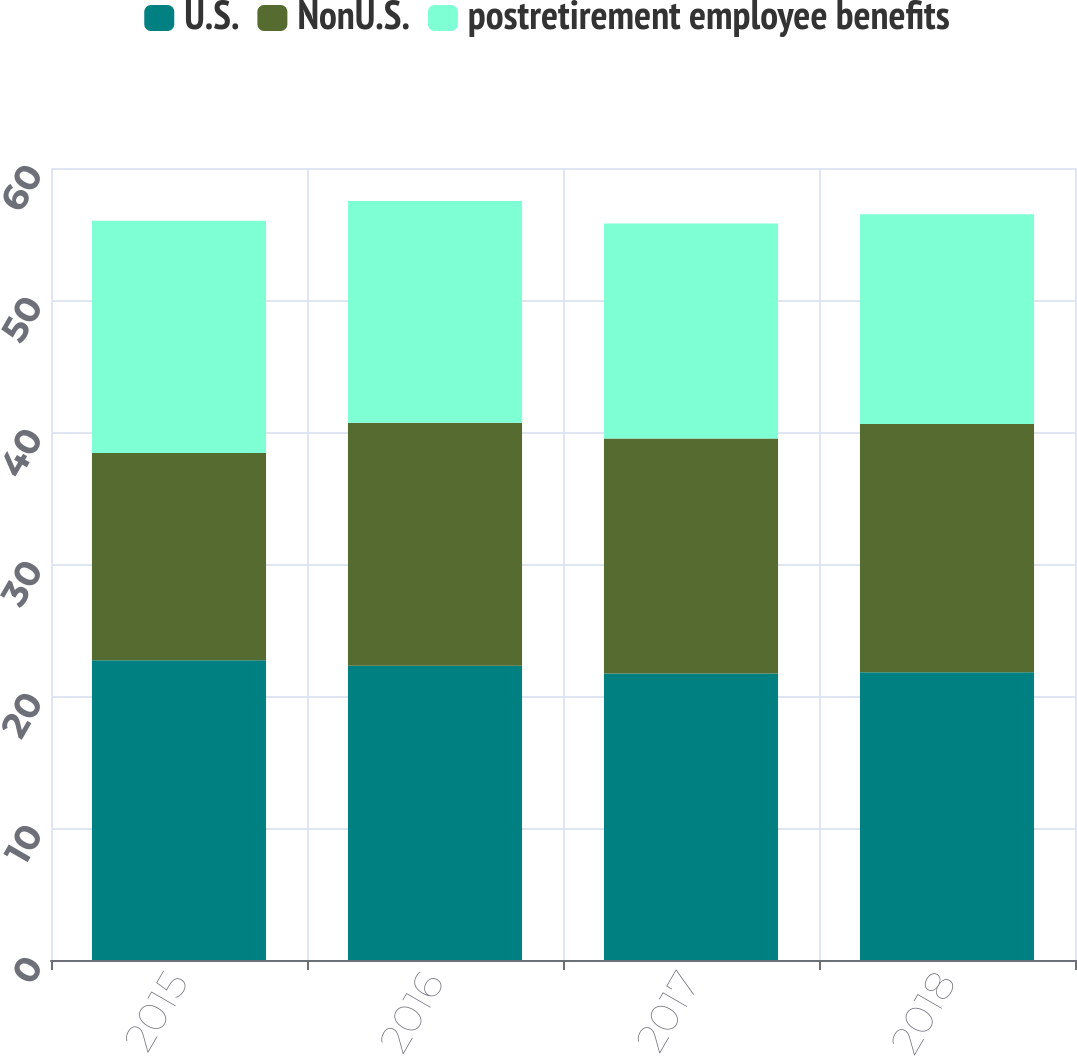Convert chart to OTSL. <chart><loc_0><loc_0><loc_500><loc_500><stacked_bar_chart><ecel><fcel>2015<fcel>2016<fcel>2017<fcel>2018<nl><fcel>U.S.<fcel>22.7<fcel>22.3<fcel>21.7<fcel>21.8<nl><fcel>NonU.S.<fcel>15.7<fcel>18.4<fcel>17.8<fcel>18.8<nl><fcel>postretirement employee benefits<fcel>17.6<fcel>16.8<fcel>16.3<fcel>15.9<nl></chart> 